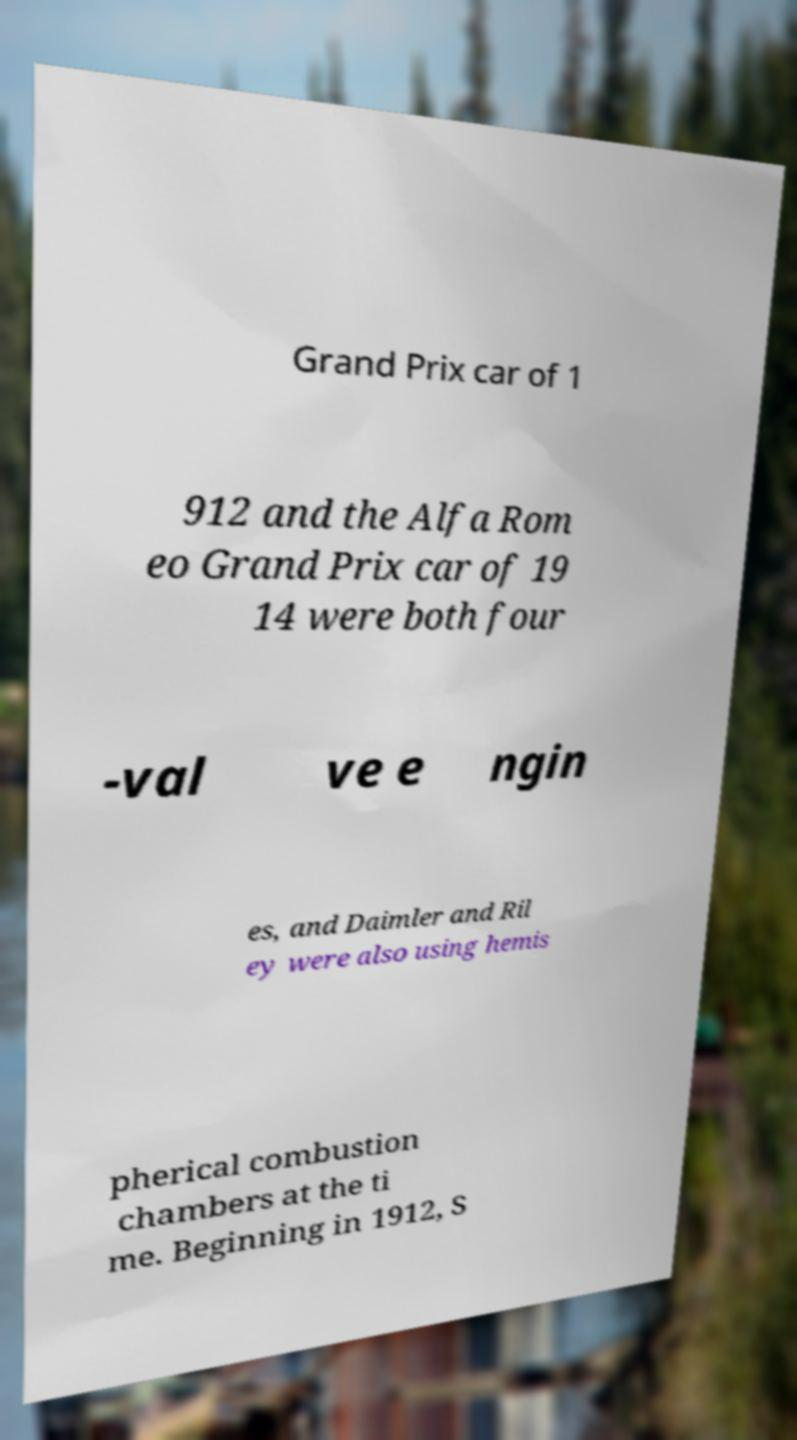For documentation purposes, I need the text within this image transcribed. Could you provide that? Grand Prix car of 1 912 and the Alfa Rom eo Grand Prix car of 19 14 were both four -val ve e ngin es, and Daimler and Ril ey were also using hemis pherical combustion chambers at the ti me. Beginning in 1912, S 